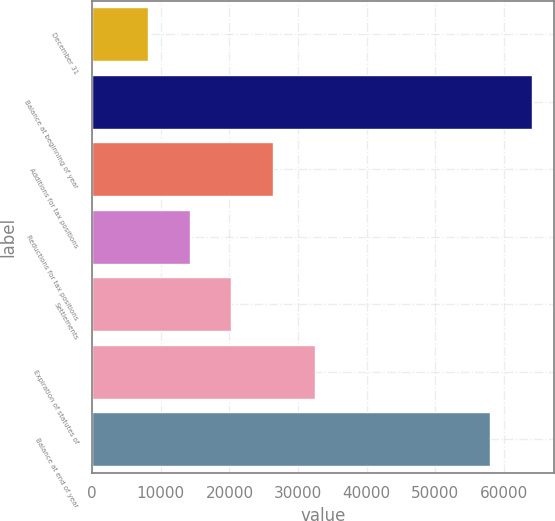<chart> <loc_0><loc_0><loc_500><loc_500><bar_chart><fcel>December 31<fcel>Balance at beginning of year<fcel>Additions for tax positions<fcel>Reductions for tax positions<fcel>Settlements<fcel>Expiration of statutes of<fcel>Balance at end of year<nl><fcel>8082.5<fcel>64106.5<fcel>26390<fcel>14185<fcel>20287.5<fcel>32492.5<fcel>58004<nl></chart> 